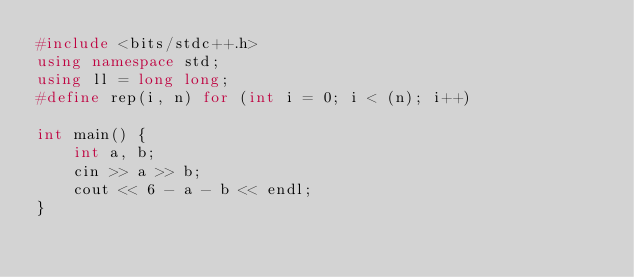<code> <loc_0><loc_0><loc_500><loc_500><_C++_>#include <bits/stdc++.h>
using namespace std;
using ll = long long;
#define rep(i, n) for (int i = 0; i < (n); i++)

int main() {
    int a, b;
    cin >> a >> b;
    cout << 6 - a - b << endl;
}</code> 